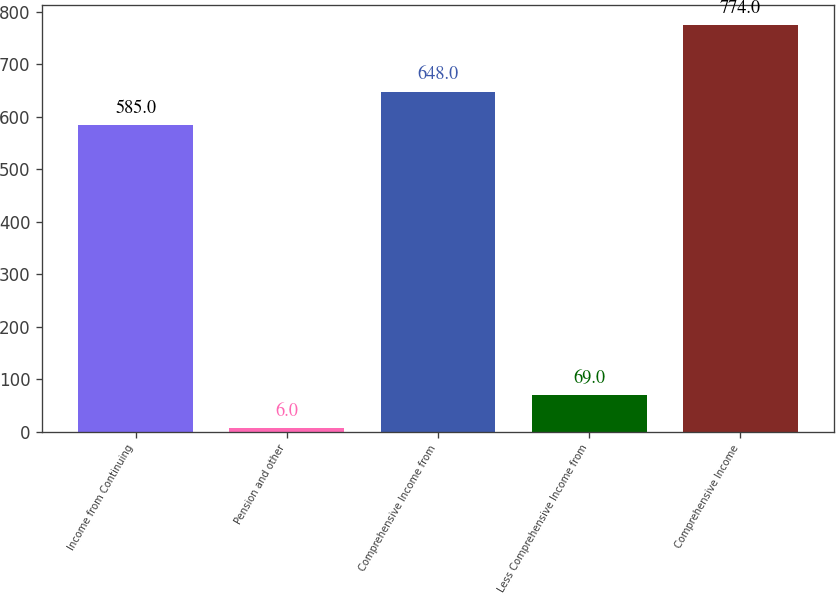Convert chart to OTSL. <chart><loc_0><loc_0><loc_500><loc_500><bar_chart><fcel>Income from Continuing<fcel>Pension and other<fcel>Comprehensive Income from<fcel>Less Comprehensive Income from<fcel>Comprehensive Income<nl><fcel>585<fcel>6<fcel>648<fcel>69<fcel>774<nl></chart> 